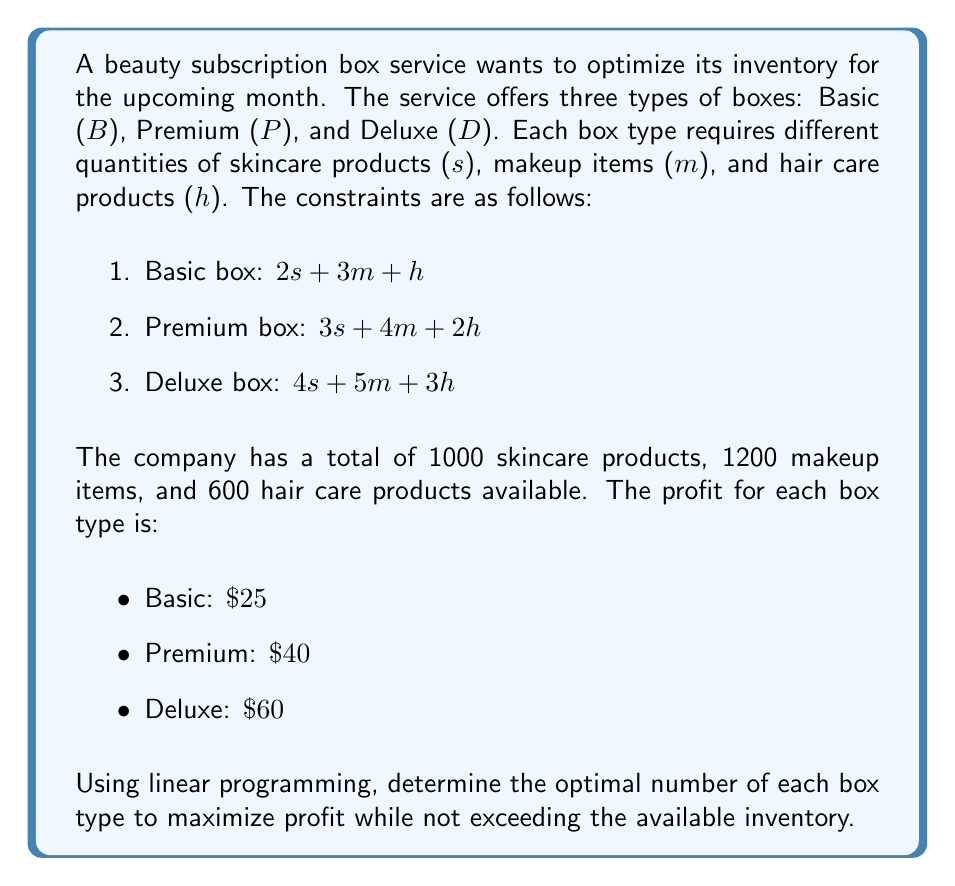What is the answer to this math problem? To solve this problem, we'll use linear programming. Let's define our variables:

$B$: Number of Basic boxes
$P$: Number of Premium boxes
$D$: Number of Deluxe boxes

Our objective function (profit) is:

$$25B + 40P + 60D$$

Our constraints are:

1. Skincare products: $2B + 3P + 4D \leq 1000$
2. Makeup items: $3B + 4P + 5D \leq 1200$
3. Hair care products: $B + 2P + 3D \leq 600$
4. Non-negativity: $B, P, D \geq 0$

To solve this, we'll use the simplex method:

1. Convert inequalities to equations by adding slack variables:
   $2B + 3P + 4D + S_1 = 1000$
   $3B + 4P + 5D + S_2 = 1200$
   $B + 2P + 3D + S_3 = 600$

2. Set up the initial tableau:

   $$\begin{array}{c|cccccccc}
     & B & P & D & S_1 & S_2 & S_3 & RHS \\
   \hline
   Z & -25 & -40 & -60 & 0 & 0 & 0 & 0 \\
   S_1 & 2 & 3 & 4 & 1 & 0 & 0 & 1000 \\
   S_2 & 3 & 4 & 5 & 0 & 1 & 0 & 1200 \\
   S_3 & 1 & 2 & 3 & 0 & 0 & 1 & 600
   \end{array}$$

3. Select the pivot column (most negative in Z row): $D$
4. Calculate ratios: $1000/4 = 250$, $1200/5 = 240$, $600/3 = 200$
5. Select pivot row (smallest positive ratio): $S_3$
6. Perform row operations to get:

   $$\begin{array}{c|cccccccc}
     & B & P & D & S_1 & S_2 & S_3 & RHS \\
   \hline
   Z & -5 & -20 & 0 & 0 & 0 & 20 & 12000 \\
   S_1 & 2/3 & 1 & 0 & 1 & 0 & -4/3 & 200 \\
   S_2 & 1 & 2/3 & 0 & 0 & 1 & -5/3 & 400 \\
   D & 1/3 & 2/3 & 1 & 0 & 0 & 1/3 & 200
   \end{array}$$

7. Repeat steps 3-6 until no negative values remain in Z row.

Final optimal solution:
$B = 0$, $P = 200$, $D = 200$

Maximum profit: $200 * \$40 + 200 * \$60 = \$20,000$
Answer: The optimal solution is to produce 200 Premium boxes and 200 Deluxe boxes, resulting in a maximum profit of $20,000. 